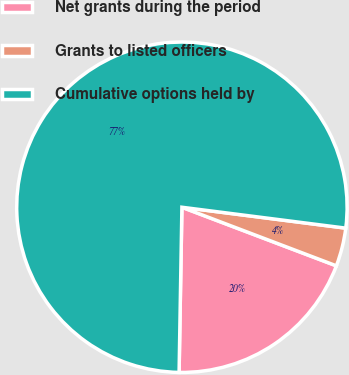Convert chart to OTSL. <chart><loc_0><loc_0><loc_500><loc_500><pie_chart><fcel>Net grants during the period<fcel>Grants to listed officers<fcel>Cumulative options held by<nl><fcel>19.5%<fcel>3.75%<fcel>76.74%<nl></chart> 